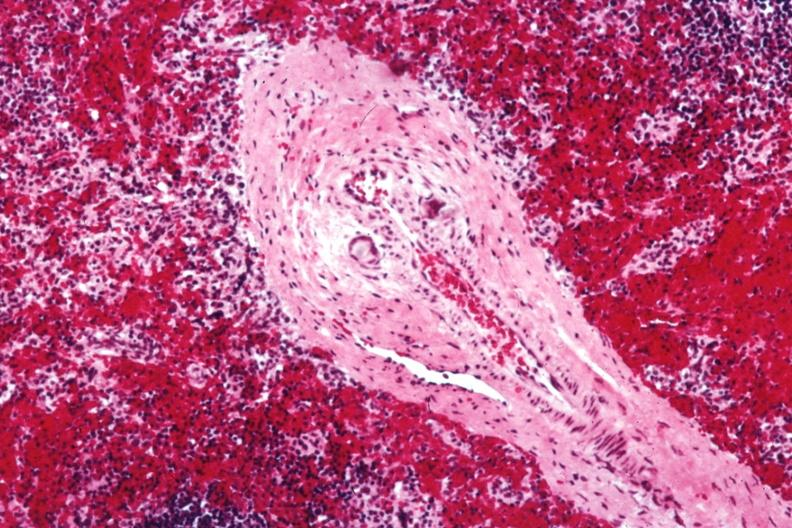s vasculitis foreign body present?
Answer the question using a single word or phrase. Yes 